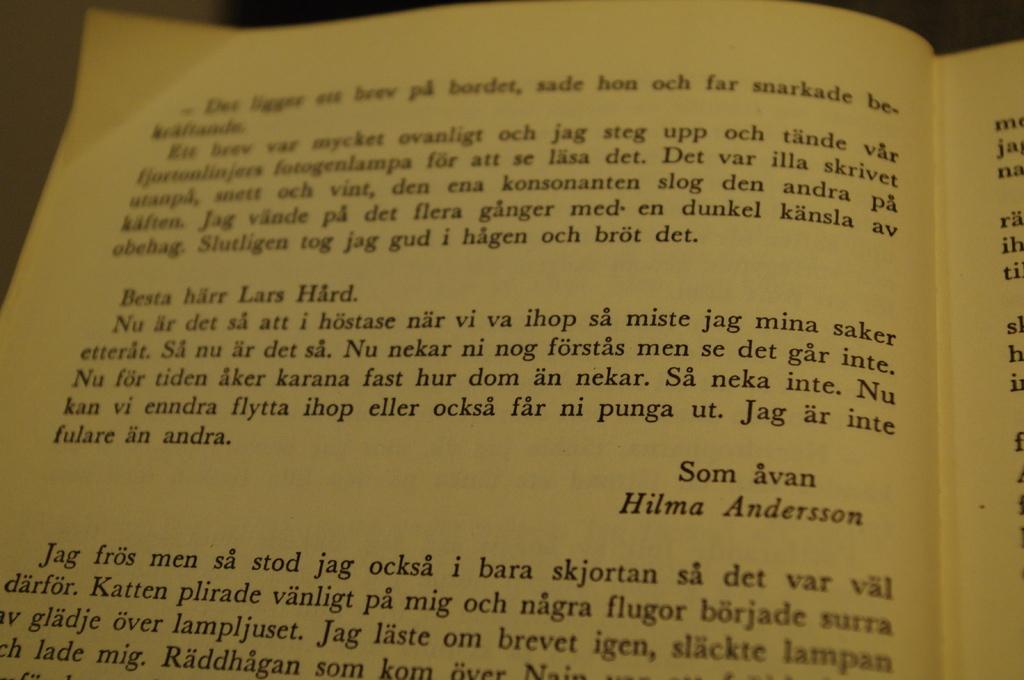What is a name on this book page?
Your response must be concise. Hilma andersson. 